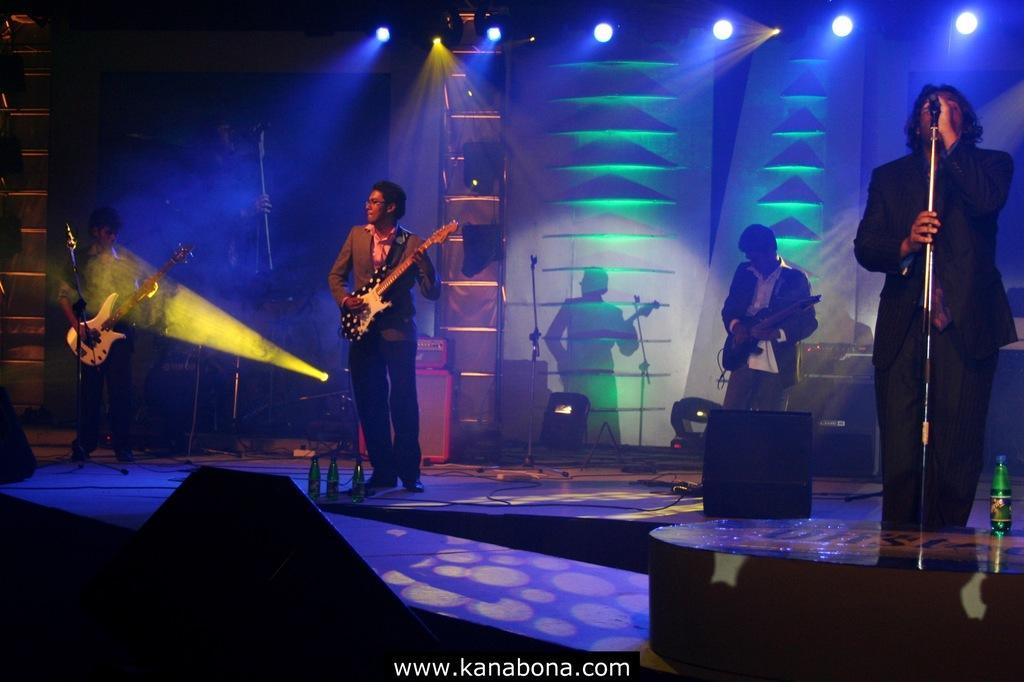Describe this image in one or two sentences. In this image we can see three people are standing and playing musical instruments. One person standing, holding a microphone and singing. There are so many objects are on the stage, some lights attached to the ceiling, some objects are attached to the wall and some microphone stands with microphone. 